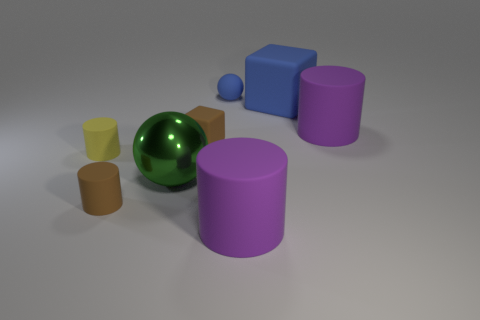Subtract all brown rubber cylinders. How many cylinders are left? 3 Subtract all green spheres. How many spheres are left? 1 Subtract all spheres. How many objects are left? 6 Subtract 1 blocks. How many blocks are left? 1 Add 6 small shiny blocks. How many small shiny blocks exist? 6 Add 1 brown rubber objects. How many objects exist? 9 Subtract 1 blue blocks. How many objects are left? 7 Subtract all purple cubes. Subtract all brown balls. How many cubes are left? 2 Subtract all cyan blocks. How many yellow cylinders are left? 1 Subtract all big purple things. Subtract all small blue matte objects. How many objects are left? 5 